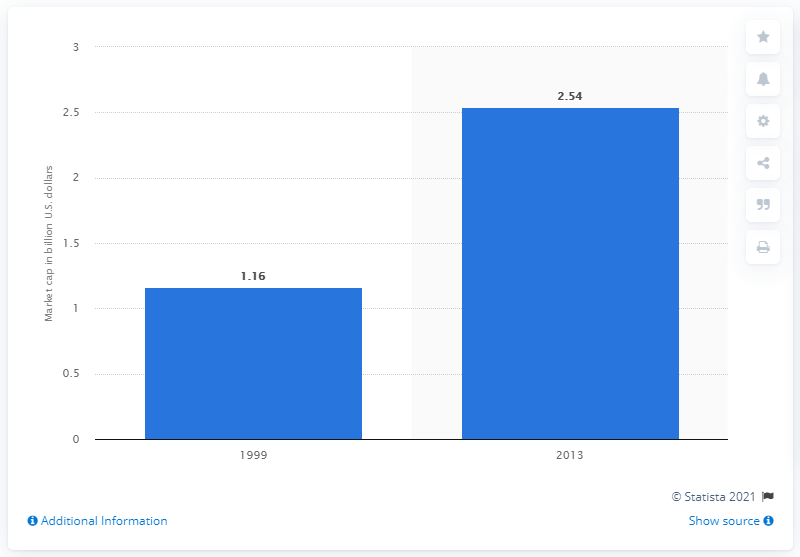Draw attention to some important aspects in this diagram. In 1999, the average market capitalization of companies listed on the NASDAQ was 1.16 trillion dollars. In 2013, the average market capitalization of companies listed on the NASDAQ was approximately 2.54. 